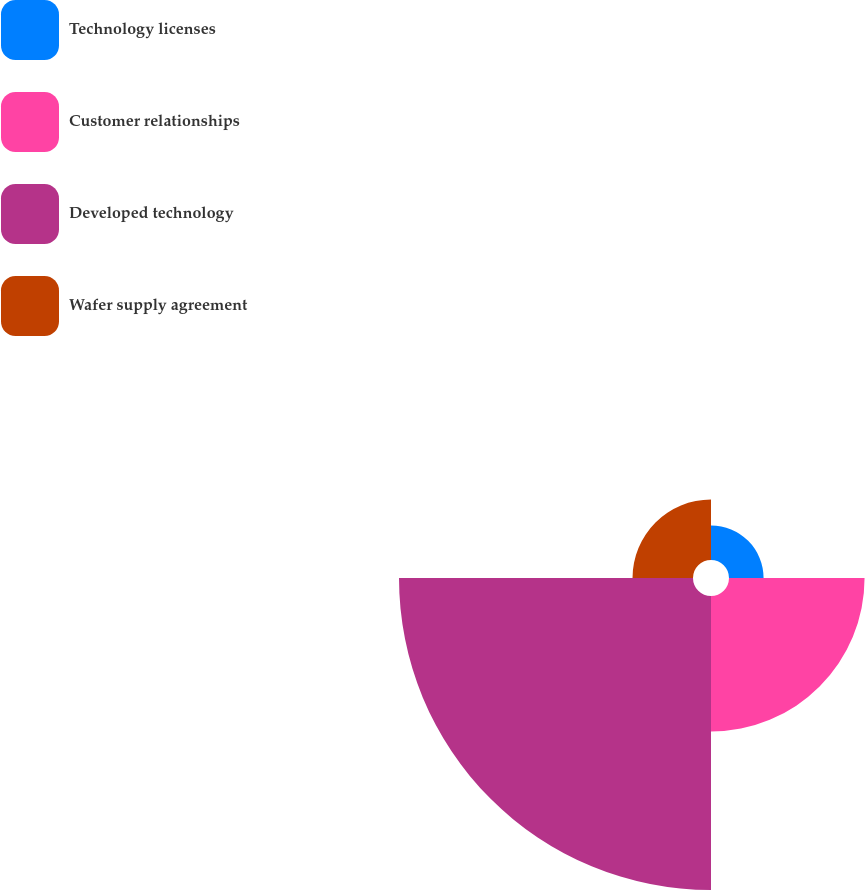Convert chart to OTSL. <chart><loc_0><loc_0><loc_500><loc_500><pie_chart><fcel>Technology licenses<fcel>Customer relationships<fcel>Developed technology<fcel>Wafer supply agreement<nl><fcel>6.59%<fcel>25.84%<fcel>56.04%<fcel>11.53%<nl></chart> 